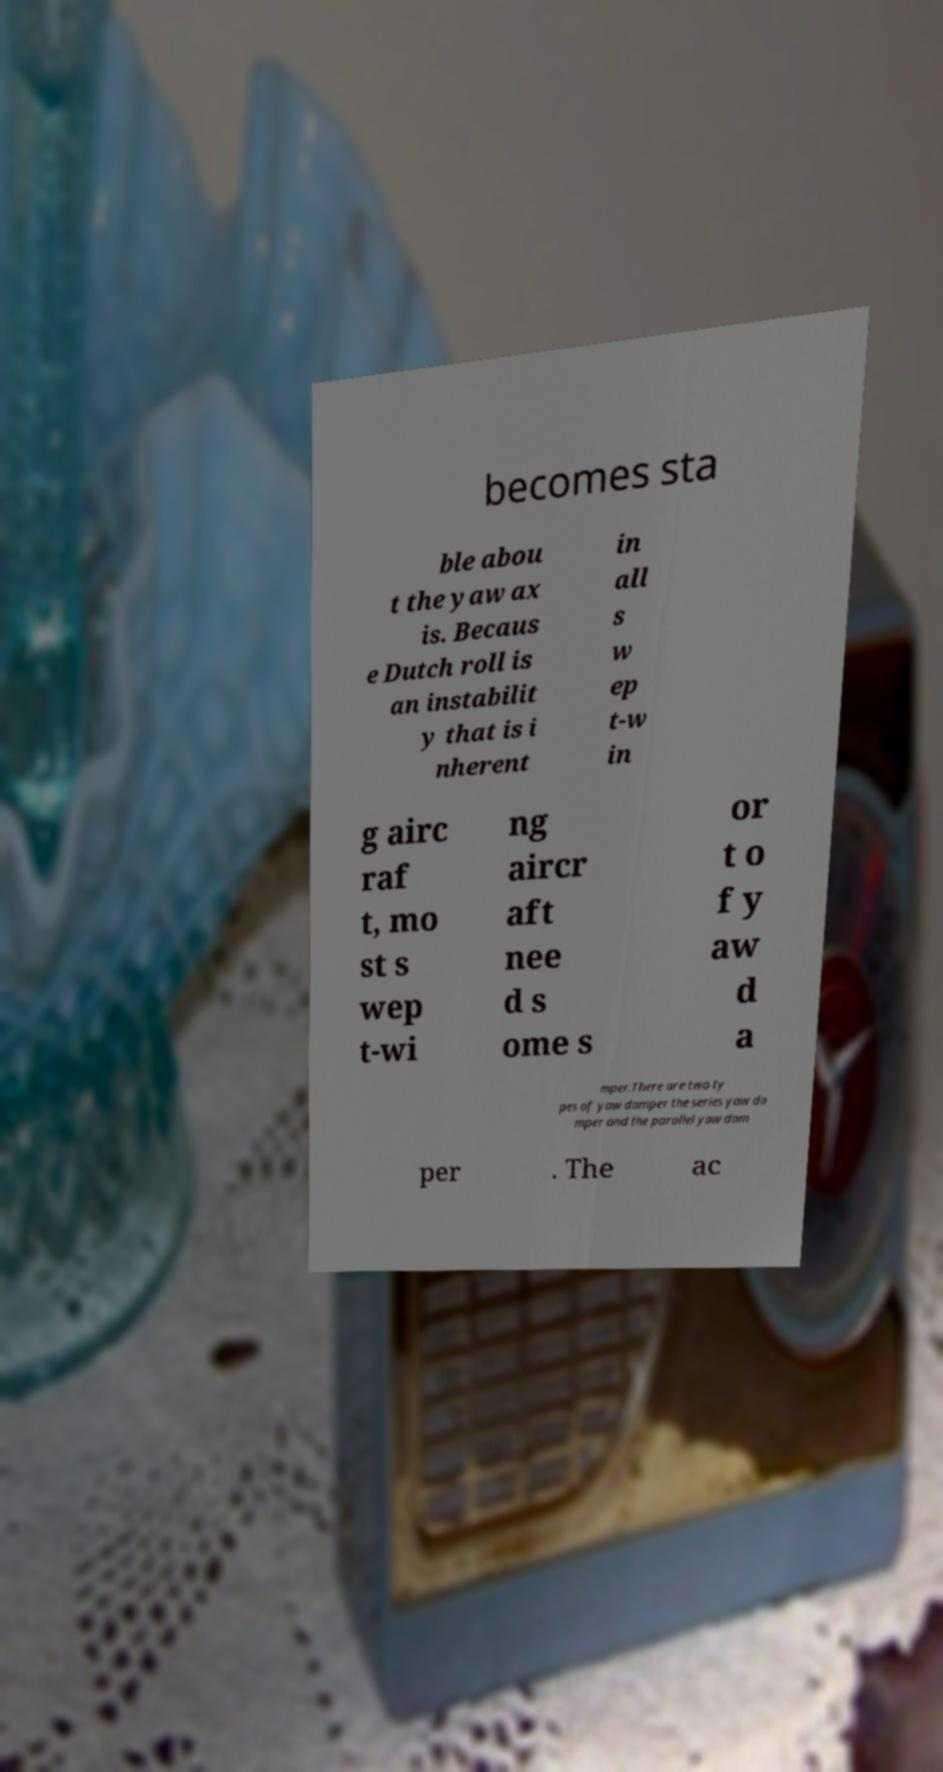Could you assist in decoding the text presented in this image and type it out clearly? becomes sta ble abou t the yaw ax is. Becaus e Dutch roll is an instabilit y that is i nherent in all s w ep t-w in g airc raf t, mo st s wep t-wi ng aircr aft nee d s ome s or t o f y aw d a mper.There are two ty pes of yaw damper the series yaw da mper and the parallel yaw dam per . The ac 